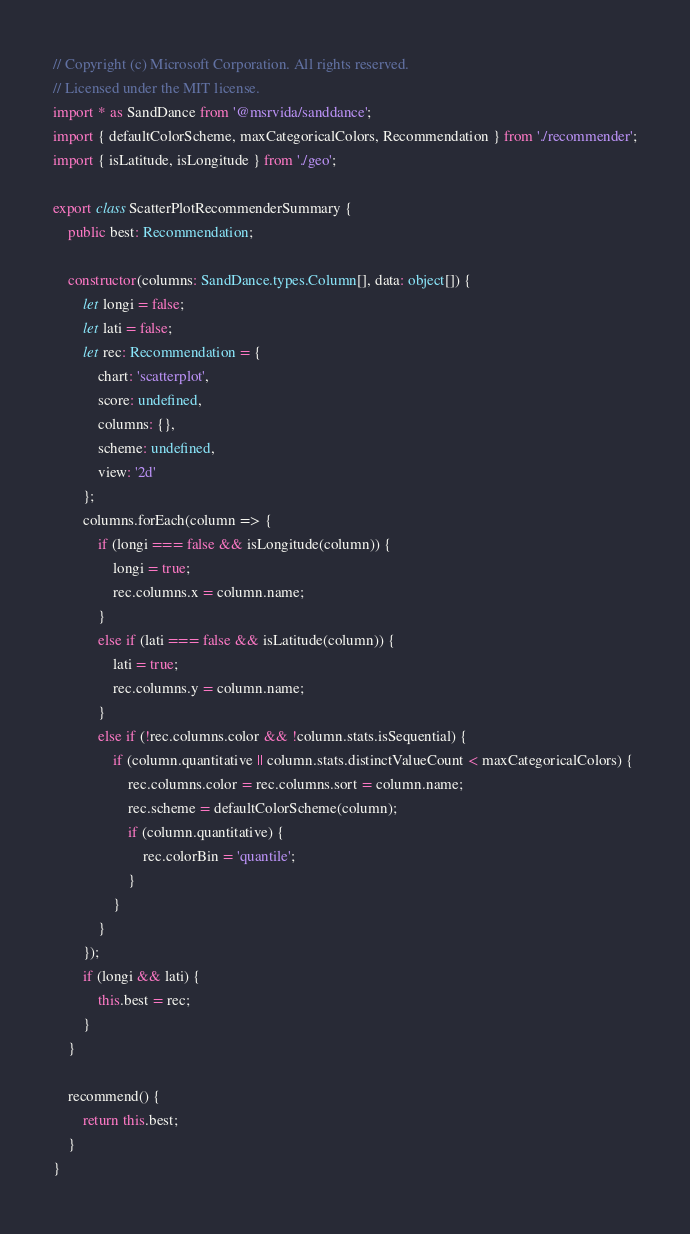Convert code to text. <code><loc_0><loc_0><loc_500><loc_500><_TypeScript_>// Copyright (c) Microsoft Corporation. All rights reserved.
// Licensed under the MIT license.
import * as SandDance from '@msrvida/sanddance';
import { defaultColorScheme, maxCategoricalColors, Recommendation } from './recommender';
import { isLatitude, isLongitude } from './geo';

export class ScatterPlotRecommenderSummary {
    public best: Recommendation;

    constructor(columns: SandDance.types.Column[], data: object[]) {
        let longi = false;
        let lati = false;
        let rec: Recommendation = {
            chart: 'scatterplot',
            score: undefined,
            columns: {},
            scheme: undefined,
            view: '2d'
        };
        columns.forEach(column => {
            if (longi === false && isLongitude(column)) {
                longi = true;
                rec.columns.x = column.name;
            }
            else if (lati === false && isLatitude(column)) {
                lati = true;
                rec.columns.y = column.name;
            }
            else if (!rec.columns.color && !column.stats.isSequential) {
                if (column.quantitative || column.stats.distinctValueCount < maxCategoricalColors) {
                    rec.columns.color = rec.columns.sort = column.name;
                    rec.scheme = defaultColorScheme(column);
                    if (column.quantitative) {
                        rec.colorBin = 'quantile';
                    }
                }
            }
        });
        if (longi && lati) {
            this.best = rec;
        }
    }

    recommend() {
        return this.best;
    }
}</code> 